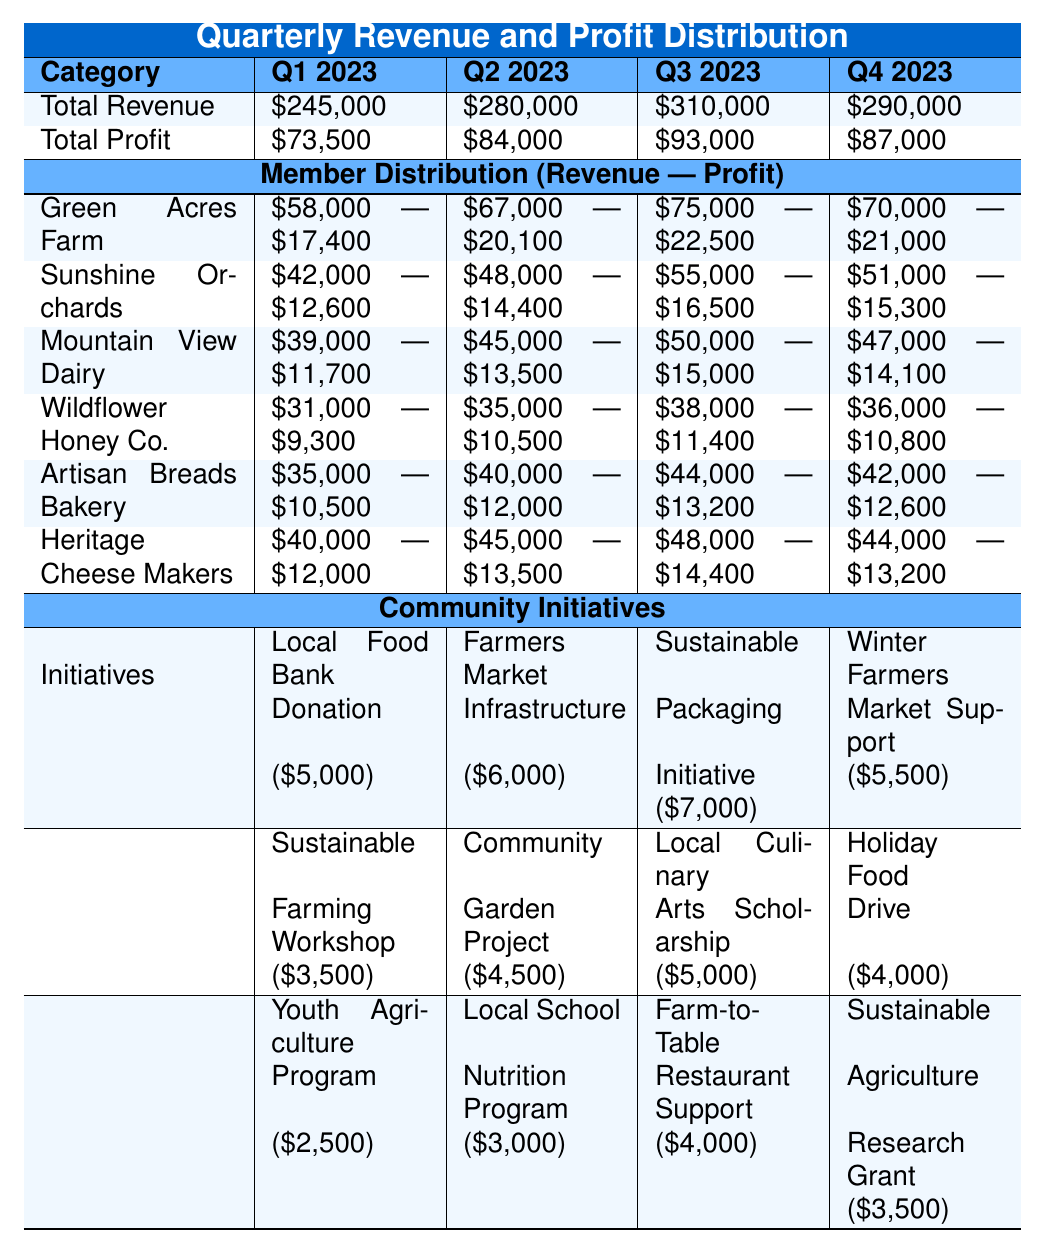What was the total revenue in Q2 2023? The table shows that the total revenue for Q2 2023 is listed under the Total Revenue row, which states \$280,000.
Answer: \$280,000 Which member had the highest profit in Q3 2023? By checking the Member Distribution section for Q3 2023, Green Acres Farm shows a profit of \$22,500, which is the highest compared to other members' profits in that quarter.
Answer: Green Acres Farm What is the total profit for all quarters combined? To find the total profit, we add the profits from all quarters: \$73,500 + \$84,000 + \$93,000 + \$87,000 = \$337,500.
Answer: \$337,500 Did Wildflower Honey Co. increase its revenue from Q2 to Q4 2023? For Q2 2023, Wildflower Honey Co. had a revenue of \$35,000, and for Q4 2023, its revenue was \$36,000. Since \$36,000 is greater than \$35,000, it indicates an increase.
Answer: Yes What was the average profit of Heritage Cheese Makers across all quarters? To find the average profit, we sum the profits for Heritage Cheese Makers: \$12,000 (Q1) + \$13,500 (Q2) + \$14,400 (Q3) + \$13,200 (Q4) = \$53,100. We then divide by 4, giving us \$53,100 / 4 = \$13,275.
Answer: \$13,275 Which community initiative received the highest funding in Q3 2023? The initiatives in Q3 are reviewed, where the Sustainable Packaging Initiative received \$7,000, while other initiatives received \$5,000 and \$4,000 respectively. \$7,000 is the highest amount received.
Answer: Sustainable Packaging Initiative Calculate the total revenue of all member distributions in Q1 2023. For Q1 2023, we sum the revenues for all members: \$58,000 + \$42,000 + \$39,000 + \$31,000 + \$35,000 + \$40,000 = \$245,000, which matches the total revenue for the quarter, confirming our calculation.
Answer: \$245,000 Is the total revenue for Q4 2023 greater than the total revenue for Q1 2023? Total revenue for Q4 2023 is \$290,000 and for Q1 2023 is \$245,000. Since \$290,000 is greater than \$245,000, the statement is true.
Answer: Yes What percentage of total revenue in Q3 2023 was contributed by Green Acres Farm? Green Acres Farm's revenue in Q3 2023 was \$75,000. To find the percentage, we calculate (\$75,000 / \$310,000) * 100 = approximately 24.19%.
Answer: 24.19% Which quarter had the lowest total profit? By comparing the total profits from all quarters, Q1 2023 has the lowest total profit of \$73,500 compared to the others.
Answer: Q1 2023 